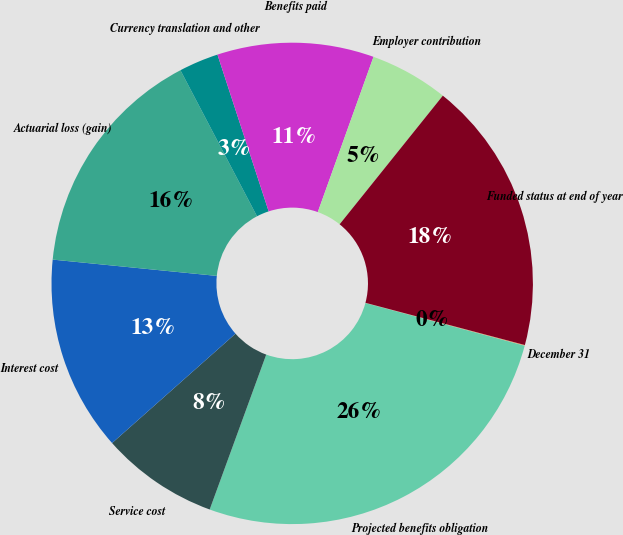Convert chart to OTSL. <chart><loc_0><loc_0><loc_500><loc_500><pie_chart><fcel>December 31<fcel>Projected benefits obligation<fcel>Service cost<fcel>Interest cost<fcel>Actuarial loss (gain)<fcel>Currency translation and other<fcel>Benefits paid<fcel>Employer contribution<fcel>Funded status at end of year<nl><fcel>0.05%<fcel>26.4%<fcel>7.89%<fcel>13.12%<fcel>15.74%<fcel>2.66%<fcel>10.51%<fcel>5.28%<fcel>18.36%<nl></chart> 